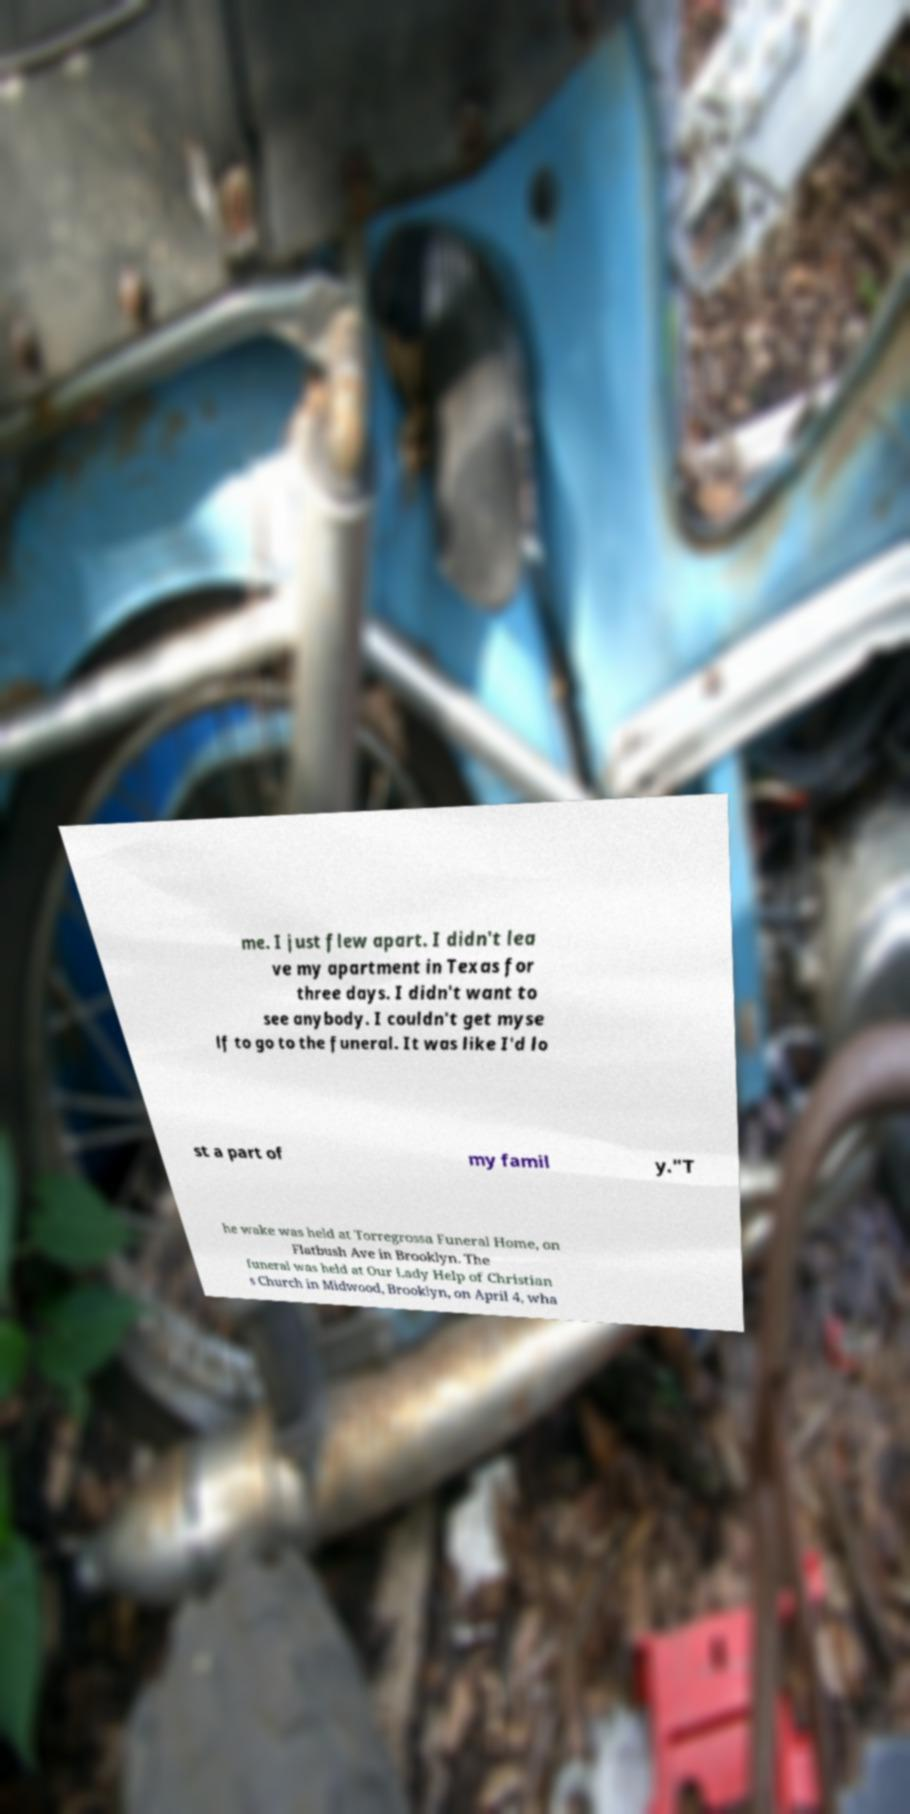Can you read and provide the text displayed in the image?This photo seems to have some interesting text. Can you extract and type it out for me? me. I just flew apart. I didn't lea ve my apartment in Texas for three days. I didn't want to see anybody. I couldn't get myse lf to go to the funeral. It was like I'd lo st a part of my famil y."T he wake was held at Torregrossa Funeral Home, on Flatbush Ave in Brooklyn. The funeral was held at Our Lady Help of Christian s Church in Midwood, Brooklyn, on April 4, wha 